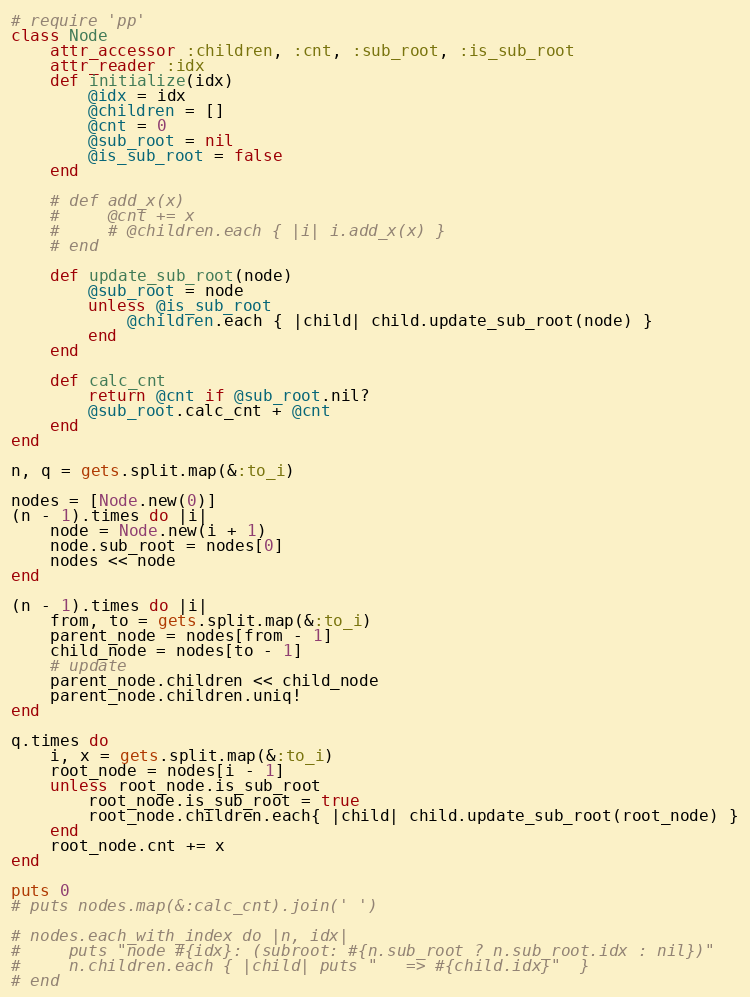<code> <loc_0><loc_0><loc_500><loc_500><_Ruby_># require 'pp'
class Node
    attr_accessor :children, :cnt, :sub_root, :is_sub_root
    attr_reader :idx
    def initialize(idx)
        @idx = idx
        @children = []
        @cnt = 0
        @sub_root = nil
        @is_sub_root = false
    end

    # def add_x(x)
    #     @cnt += x
    #     # @children.each { |i| i.add_x(x) }
    # end

    def update_sub_root(node)
        @sub_root = node
        unless @is_sub_root
            @children.each { |child| child.update_sub_root(node) }
        end
    end

    def calc_cnt
        return @cnt if @sub_root.nil?
        @sub_root.calc_cnt + @cnt
    end
end

n, q = gets.split.map(&:to_i)

nodes = [Node.new(0)]
(n - 1).times do |i| 
    node = Node.new(i + 1)
    node.sub_root = nodes[0]
    nodes << node
end

(n - 1).times do |i|
    from, to = gets.split.map(&:to_i)
    parent_node = nodes[from - 1]
    child_node = nodes[to - 1]
    # update
    parent_node.children << child_node
    parent_node.children.uniq!
end

q.times do
    i, x = gets.split.map(&:to_i)
    root_node = nodes[i - 1]
    unless root_node.is_sub_root
        root_node.is_sub_root = true
        root_node.children.each{ |child| child.update_sub_root(root_node) }
    end
    root_node.cnt += x
end

puts 0
# puts nodes.map(&:calc_cnt).join(' ')

# nodes.each_with_index do |n, idx|
#     puts "node #{idx}: (subroot: #{n.sub_root ? n.sub_root.idx : nil})"
#     n.children.each { |child| puts "   => #{child.idx}"  }
# end

</code> 